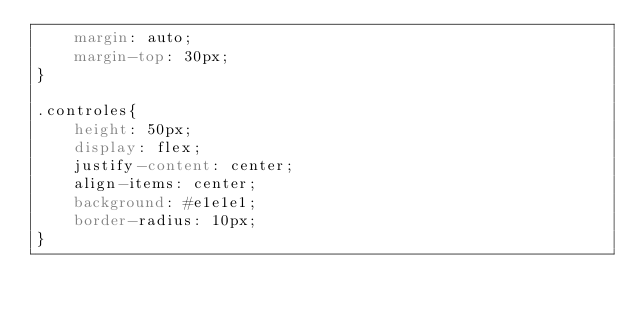Convert code to text. <code><loc_0><loc_0><loc_500><loc_500><_CSS_>    margin: auto;
    margin-top: 30px;
}

.controles{
    height: 50px;
    display: flex;
    justify-content: center;
    align-items: center;
    background: #e1e1e1;
    border-radius: 10px;
}</code> 